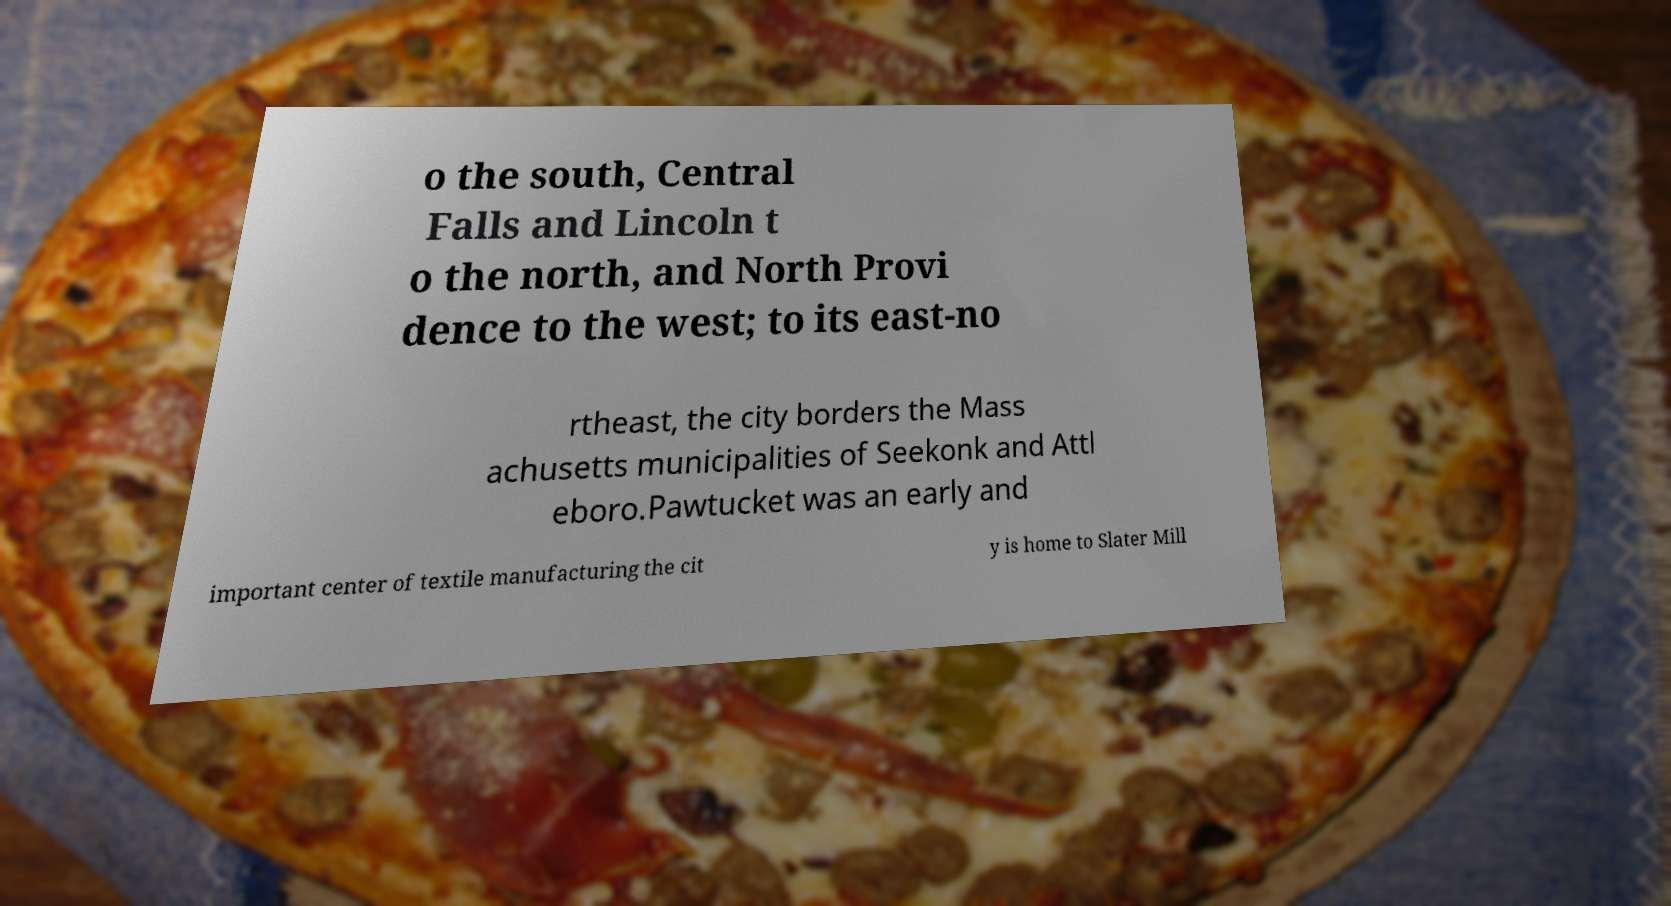There's text embedded in this image that I need extracted. Can you transcribe it verbatim? o the south, Central Falls and Lincoln t o the north, and North Provi dence to the west; to its east-no rtheast, the city borders the Mass achusetts municipalities of Seekonk and Attl eboro.Pawtucket was an early and important center of textile manufacturing the cit y is home to Slater Mill 